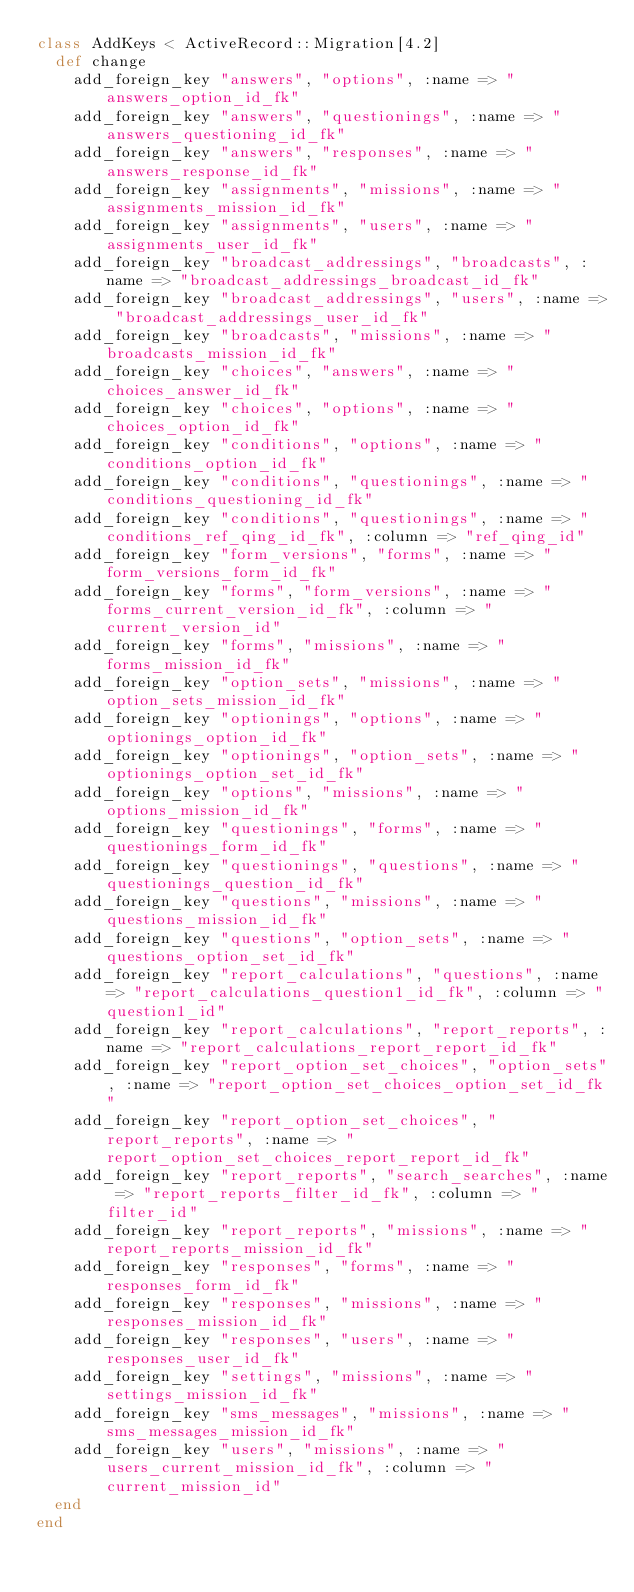<code> <loc_0><loc_0><loc_500><loc_500><_Ruby_>class AddKeys < ActiveRecord::Migration[4.2]
  def change
    add_foreign_key "answers", "options", :name => "answers_option_id_fk"
    add_foreign_key "answers", "questionings", :name => "answers_questioning_id_fk"
    add_foreign_key "answers", "responses", :name => "answers_response_id_fk"
    add_foreign_key "assignments", "missions", :name => "assignments_mission_id_fk"
    add_foreign_key "assignments", "users", :name => "assignments_user_id_fk"
    add_foreign_key "broadcast_addressings", "broadcasts", :name => "broadcast_addressings_broadcast_id_fk"
    add_foreign_key "broadcast_addressings", "users", :name => "broadcast_addressings_user_id_fk"
    add_foreign_key "broadcasts", "missions", :name => "broadcasts_mission_id_fk"
    add_foreign_key "choices", "answers", :name => "choices_answer_id_fk"
    add_foreign_key "choices", "options", :name => "choices_option_id_fk"
    add_foreign_key "conditions", "options", :name => "conditions_option_id_fk"
    add_foreign_key "conditions", "questionings", :name => "conditions_questioning_id_fk"
    add_foreign_key "conditions", "questionings", :name => "conditions_ref_qing_id_fk", :column => "ref_qing_id"
    add_foreign_key "form_versions", "forms", :name => "form_versions_form_id_fk"
    add_foreign_key "forms", "form_versions", :name => "forms_current_version_id_fk", :column => "current_version_id"
    add_foreign_key "forms", "missions", :name => "forms_mission_id_fk"
    add_foreign_key "option_sets", "missions", :name => "option_sets_mission_id_fk"
    add_foreign_key "optionings", "options", :name => "optionings_option_id_fk"
    add_foreign_key "optionings", "option_sets", :name => "optionings_option_set_id_fk"
    add_foreign_key "options", "missions", :name => "options_mission_id_fk"
    add_foreign_key "questionings", "forms", :name => "questionings_form_id_fk"
    add_foreign_key "questionings", "questions", :name => "questionings_question_id_fk"
    add_foreign_key "questions", "missions", :name => "questions_mission_id_fk"
    add_foreign_key "questions", "option_sets", :name => "questions_option_set_id_fk"
    add_foreign_key "report_calculations", "questions", :name => "report_calculations_question1_id_fk", :column => "question1_id"
    add_foreign_key "report_calculations", "report_reports", :name => "report_calculations_report_report_id_fk"
    add_foreign_key "report_option_set_choices", "option_sets", :name => "report_option_set_choices_option_set_id_fk"
    add_foreign_key "report_option_set_choices", "report_reports", :name => "report_option_set_choices_report_report_id_fk"
    add_foreign_key "report_reports", "search_searches", :name => "report_reports_filter_id_fk", :column => "filter_id"
    add_foreign_key "report_reports", "missions", :name => "report_reports_mission_id_fk"
    add_foreign_key "responses", "forms", :name => "responses_form_id_fk"
    add_foreign_key "responses", "missions", :name => "responses_mission_id_fk"
    add_foreign_key "responses", "users", :name => "responses_user_id_fk"
    add_foreign_key "settings", "missions", :name => "settings_mission_id_fk"
    add_foreign_key "sms_messages", "missions", :name => "sms_messages_mission_id_fk"
    add_foreign_key "users", "missions", :name => "users_current_mission_id_fk", :column => "current_mission_id"
  end
end
</code> 